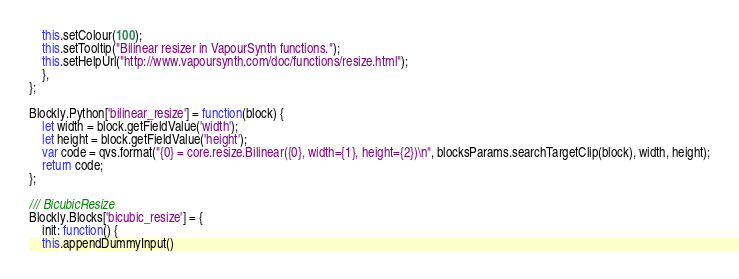<code> <loc_0><loc_0><loc_500><loc_500><_JavaScript_>    this.setColour(100);
    this.setTooltip("Bilinear resizer in VapourSynth functions.");
    this.setHelpUrl("http://www.vapoursynth.com/doc/functions/resize.html");
    },
};

Blockly.Python['bilinear_resize'] = function(block) {
    let width = block.getFieldValue('width');
    let height = block.getFieldValue('height');
    var code = qvs.format("{0} = core.resize.Bilinear({0}, width={1}, height={2})\n", blocksParams.searchTargetClip(block), width, height);
    return code;
};

/// BicubicResize
Blockly.Blocks['bicubic_resize'] = {
    init: function() {
    this.appendDummyInput()</code> 